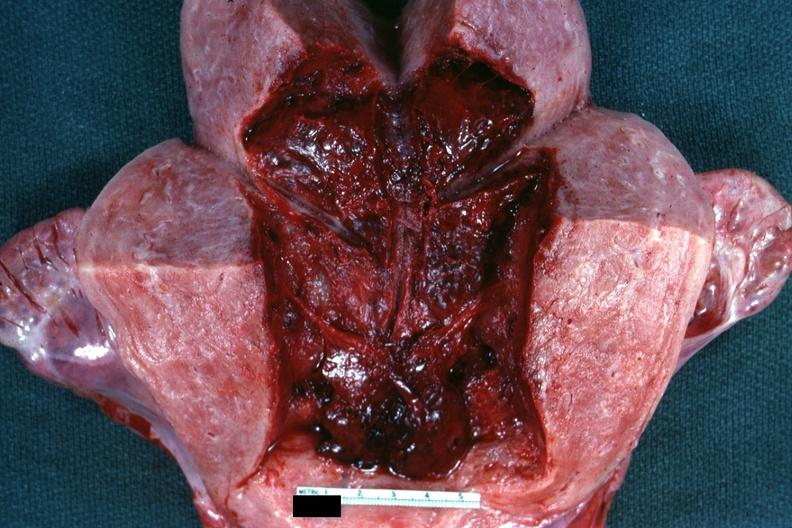what is present?
Answer the question using a single word or phrase. Postpartum 